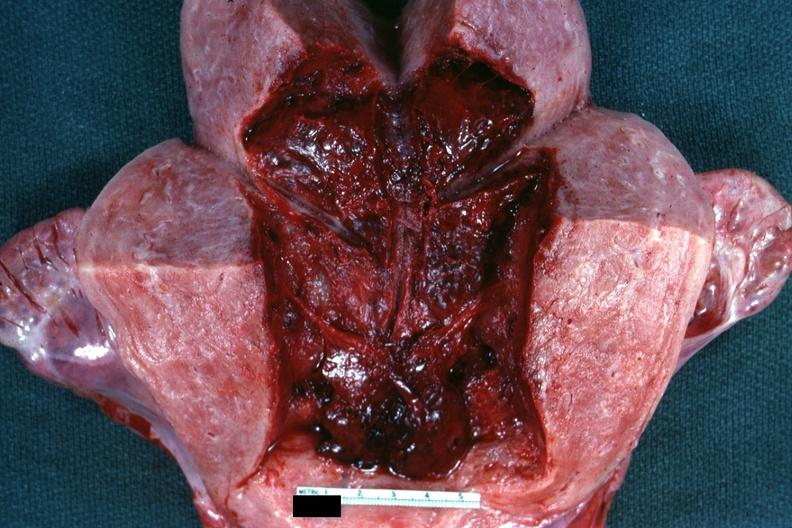what is present?
Answer the question using a single word or phrase. Postpartum 